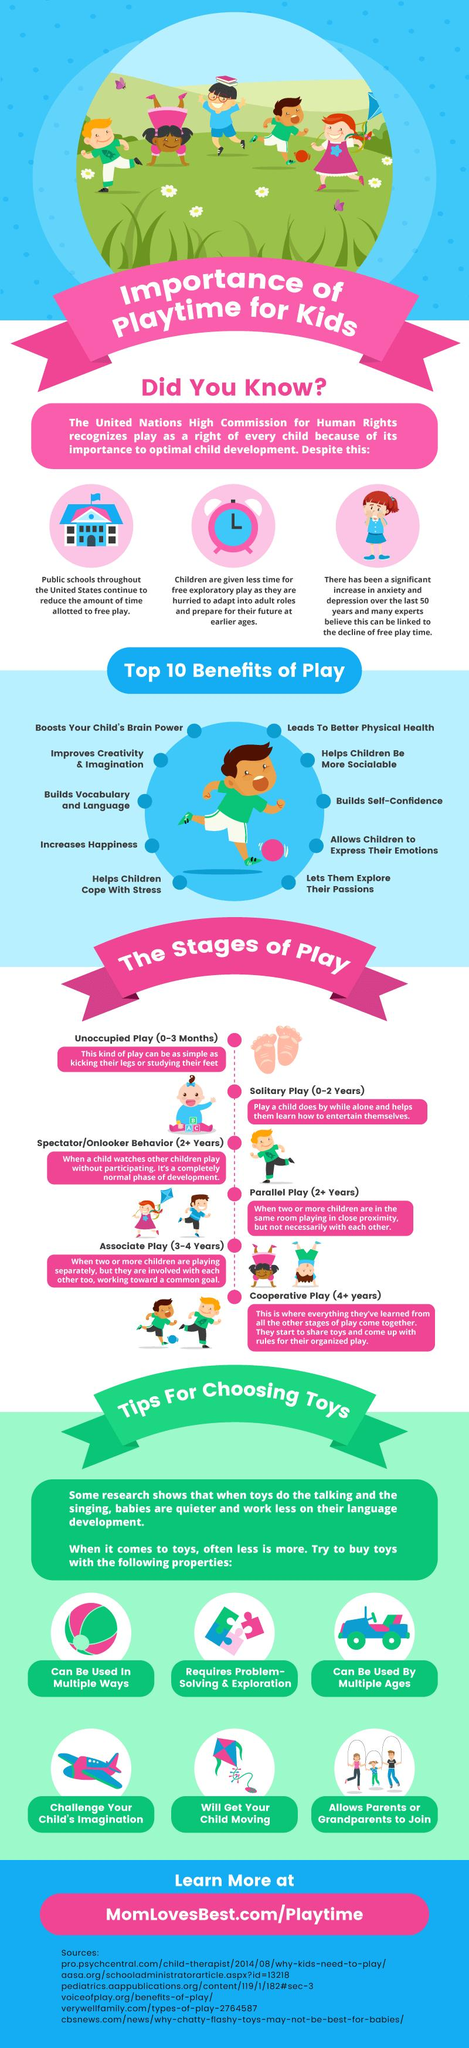Indicate a few pertinent items in this graphic. Play is known to promote social development in children. The fourth stage of play, as mentioned, is parallel play, which typically occurs at the age of 2 years. There are six stages of play depicted in this graphic. The decline of free play time in children is a potential reason for an increase in anxiety and depression. The second stage of play mentioned is Solitary Play, which typically occurs from 0-2 years of age. 